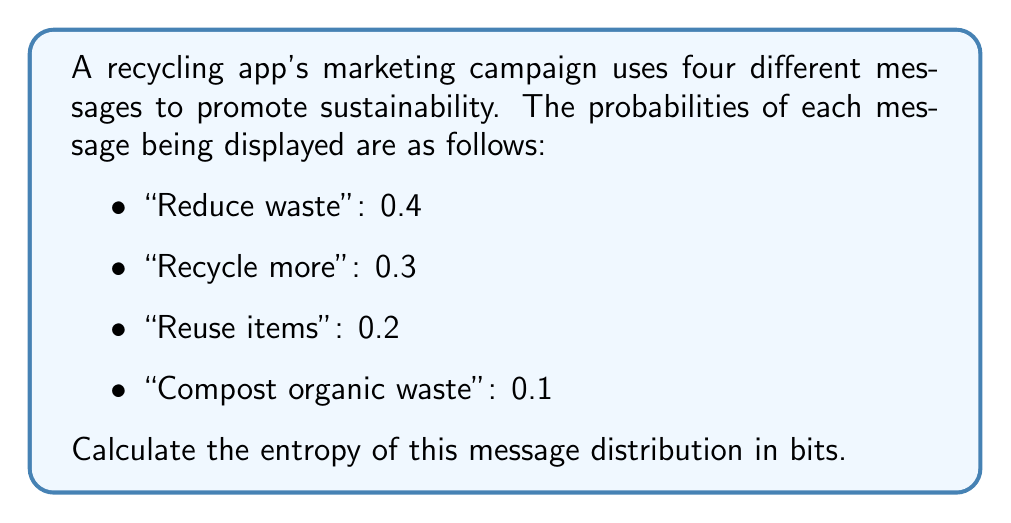Can you solve this math problem? To calculate the entropy of the message distribution, we'll use the formula for Shannon entropy:

$$H = -\sum_{i=1}^n p_i \log_2(p_i)$$

Where:
- $H$ is the entropy in bits
- $p_i$ is the probability of each message
- $n$ is the number of different messages

Let's calculate the entropy for each message:

1. "Reduce waste" ($p_1 = 0.4$):
   $-0.4 \log_2(0.4) = 0.528$ bits

2. "Recycle more" ($p_2 = 0.3$):
   $-0.3 \log_2(0.3) = 0.521$ bits

3. "Reuse items" ($p_3 = 0.2$):
   $-0.2 \log_2(0.2) = 0.464$ bits

4. "Compost organic waste" ($p_4 = 0.1$):
   $-0.1 \log_2(0.1) = 0.332$ bits

Now, we sum these values:

$$H = 0.528 + 0.521 + 0.464 + 0.332 = 1.845\text{ bits}$$

This entropy value indicates the average amount of information conveyed by each message in the marketing campaign.
Answer: $1.845\text{ bits}$ 